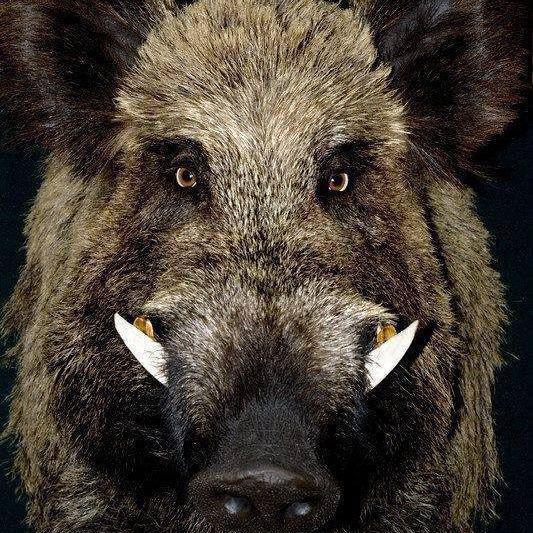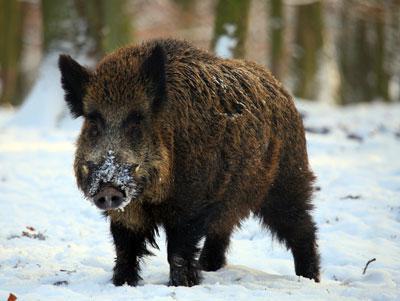The first image is the image on the left, the second image is the image on the right. Analyze the images presented: Is the assertion "There are exactly three animals." valid? Answer yes or no. No. 